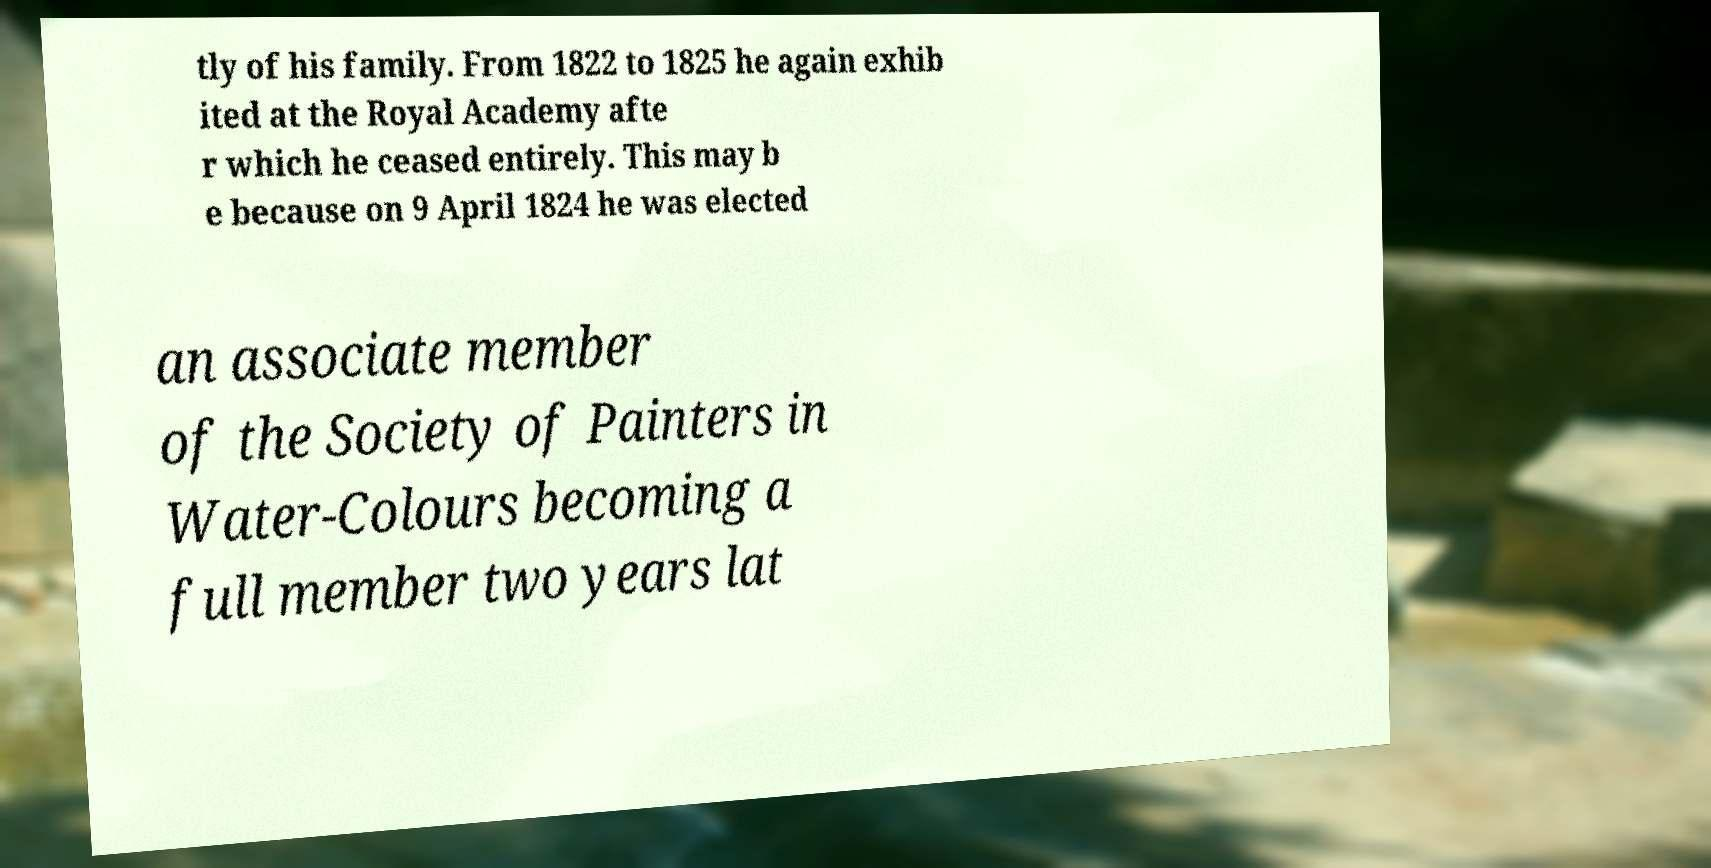Please read and relay the text visible in this image. What does it say? tly of his family. From 1822 to 1825 he again exhib ited at the Royal Academy afte r which he ceased entirely. This may b e because on 9 April 1824 he was elected an associate member of the Society of Painters in Water-Colours becoming a full member two years lat 